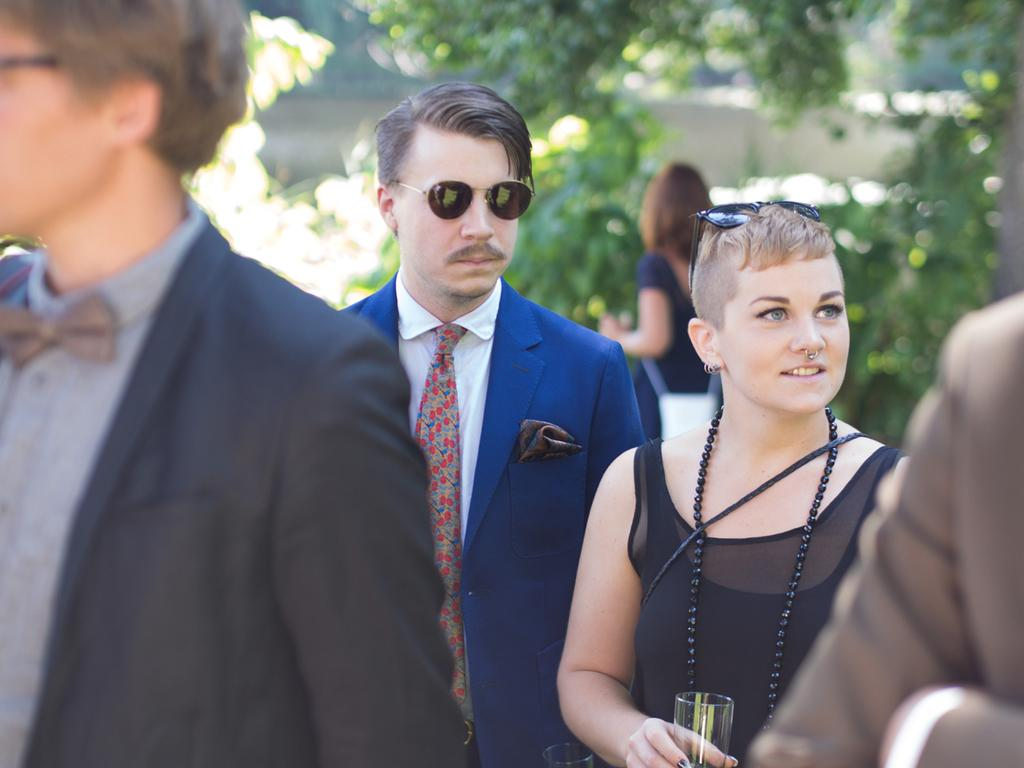What is happening on the road in the image? There is a group of people on the road in the image. What can be seen in the background of the image? There are trees and a fence in the background of the image. What might be the weather condition during the time the image was taken? The image was likely taken during a sunny day. Is there a property dispute happening between the people in the image? There is no indication of a property dispute or any argument in the image; it simply shows a group of people on the road. 